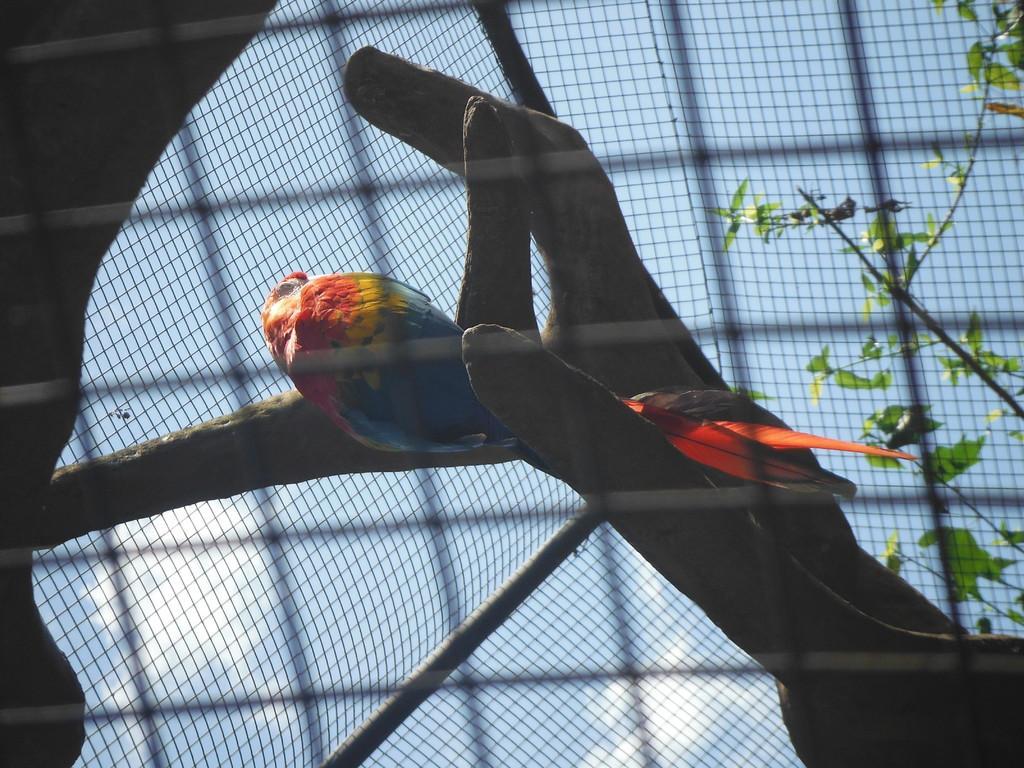Could you give a brief overview of what you see in this image? In the center of the image we can see a parrot on the branch. On the right there is a tree. In the background there is a mesh and sky. 